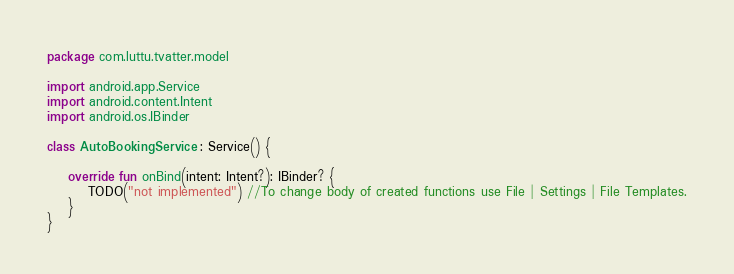Convert code to text. <code><loc_0><loc_0><loc_500><loc_500><_Kotlin_>package com.luttu.tvatter.model

import android.app.Service
import android.content.Intent
import android.os.IBinder

class AutoBookingService : Service() {

    override fun onBind(intent: Intent?): IBinder? {
        TODO("not implemented") //To change body of created functions use File | Settings | File Templates.
    }
}</code> 